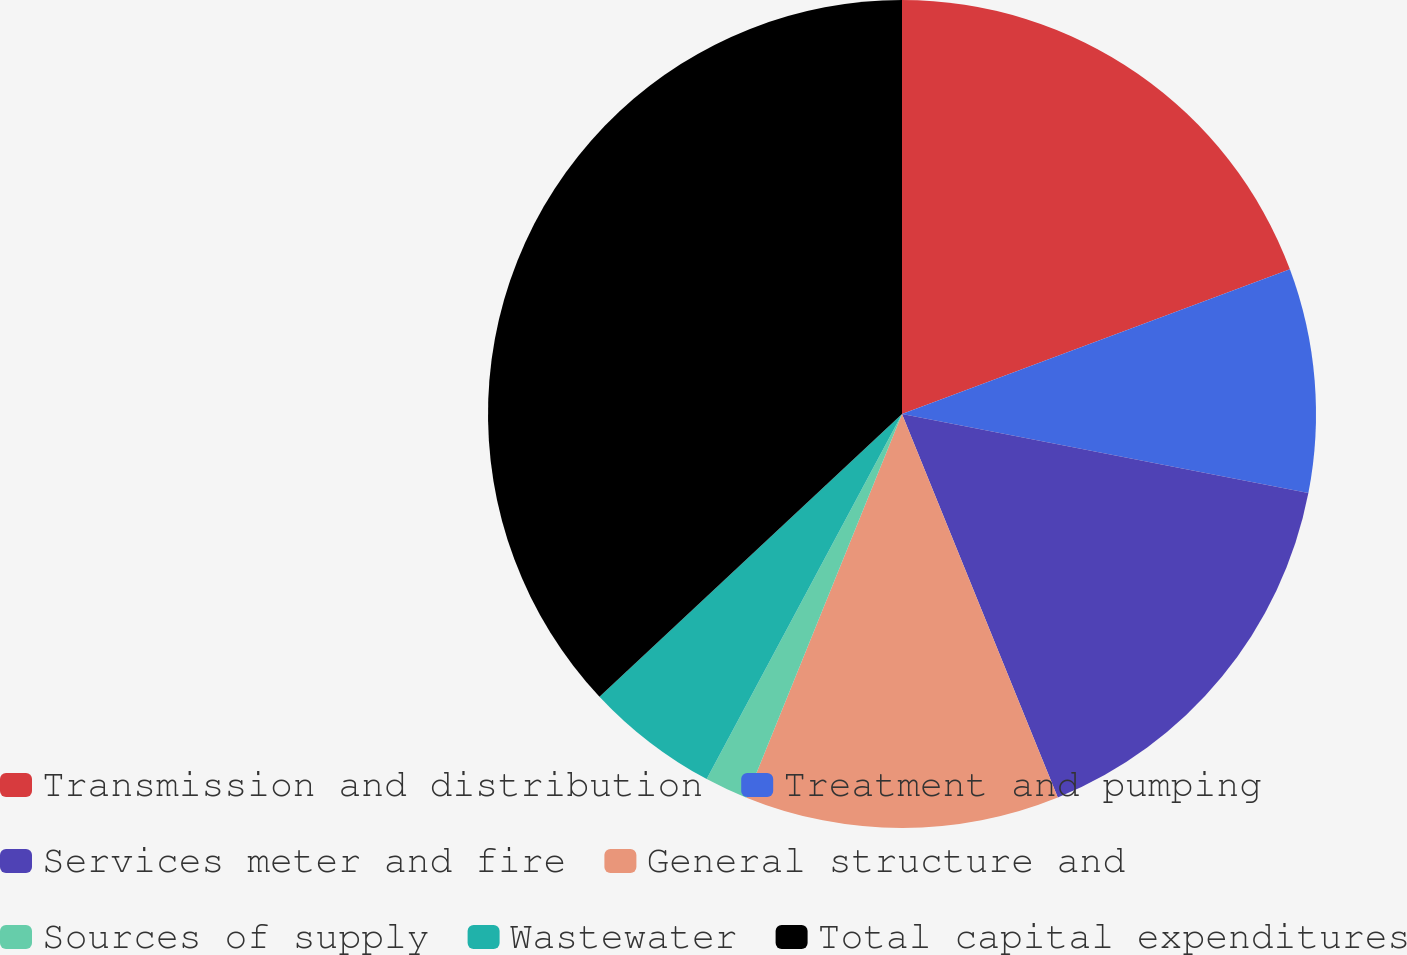Convert chart to OTSL. <chart><loc_0><loc_0><loc_500><loc_500><pie_chart><fcel>Transmission and distribution<fcel>Treatment and pumping<fcel>Services meter and fire<fcel>General structure and<fcel>Sources of supply<fcel>Wastewater<fcel>Total capital expenditures<nl><fcel>19.32%<fcel>8.74%<fcel>15.8%<fcel>12.27%<fcel>1.69%<fcel>5.22%<fcel>36.96%<nl></chart> 